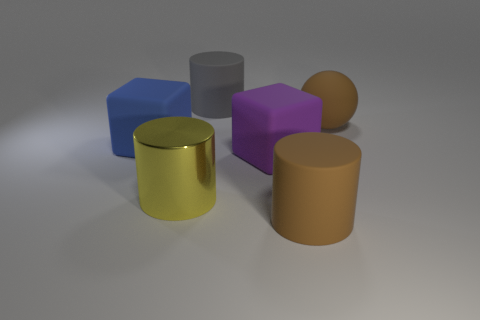Are there any other things that are made of the same material as the yellow thing?
Keep it short and to the point. No. What number of other things are there of the same color as the ball?
Make the answer very short. 1. There is a big rubber block in front of the block that is to the left of the gray cylinder; what color is it?
Offer a very short reply. Purple. Are there any rubber cylinders of the same color as the shiny object?
Make the answer very short. No. How many matte objects are either large yellow objects or brown balls?
Your response must be concise. 1. Is there a blue cube that has the same material as the yellow cylinder?
Provide a succinct answer. No. What number of big matte things are both left of the large purple rubber object and behind the big blue rubber cube?
Your answer should be very brief. 1. Are there fewer metallic objects right of the big gray thing than big cubes in front of the blue rubber cube?
Offer a terse response. Yes. Is the shape of the gray object the same as the big yellow object?
Provide a succinct answer. Yes. What number of other objects are the same size as the blue matte thing?
Ensure brevity in your answer.  5. 